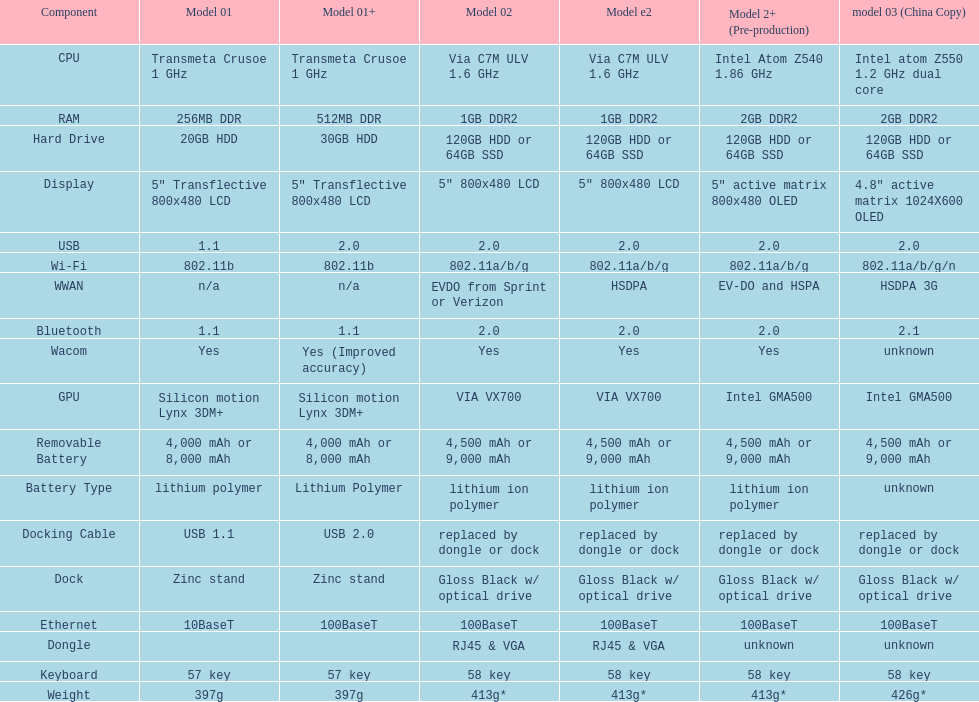How much heavier is model 3 compared to model 1? 29g. 